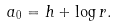Convert formula to latex. <formula><loc_0><loc_0><loc_500><loc_500>a _ { 0 } = h + \log r .</formula> 